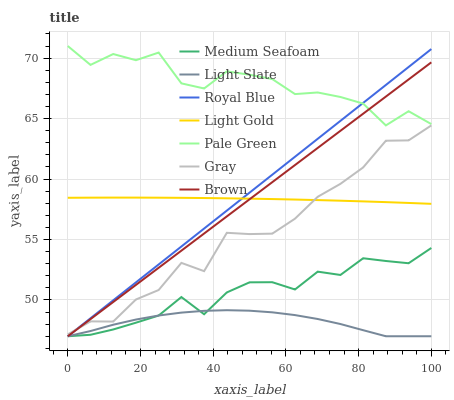Does Light Slate have the minimum area under the curve?
Answer yes or no. Yes. Does Pale Green have the maximum area under the curve?
Answer yes or no. Yes. Does Brown have the minimum area under the curve?
Answer yes or no. No. Does Brown have the maximum area under the curve?
Answer yes or no. No. Is Brown the smoothest?
Answer yes or no. Yes. Is Pale Green the roughest?
Answer yes or no. Yes. Is Light Slate the smoothest?
Answer yes or no. No. Is Light Slate the roughest?
Answer yes or no. No. Does Brown have the lowest value?
Answer yes or no. Yes. Does Pale Green have the lowest value?
Answer yes or no. No. Does Pale Green have the highest value?
Answer yes or no. Yes. Does Brown have the highest value?
Answer yes or no. No. Is Light Slate less than Gray?
Answer yes or no. Yes. Is Gray greater than Medium Seafoam?
Answer yes or no. Yes. Does Brown intersect Pale Green?
Answer yes or no. Yes. Is Brown less than Pale Green?
Answer yes or no. No. Is Brown greater than Pale Green?
Answer yes or no. No. Does Light Slate intersect Gray?
Answer yes or no. No. 